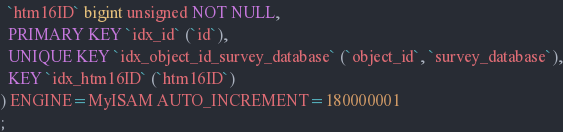Convert code to text. <code><loc_0><loc_0><loc_500><loc_500><_SQL_>  `htm16ID` bigint unsigned NOT NULL,
  PRIMARY KEY `idx_id` (`id`),
  UNIQUE KEY `idx_object_id_survey_database` (`object_id`, `survey_database`),
  KEY `idx_htm16ID` (`htm16ID`)
) ENGINE=MyISAM AUTO_INCREMENT=180000001
;
</code> 